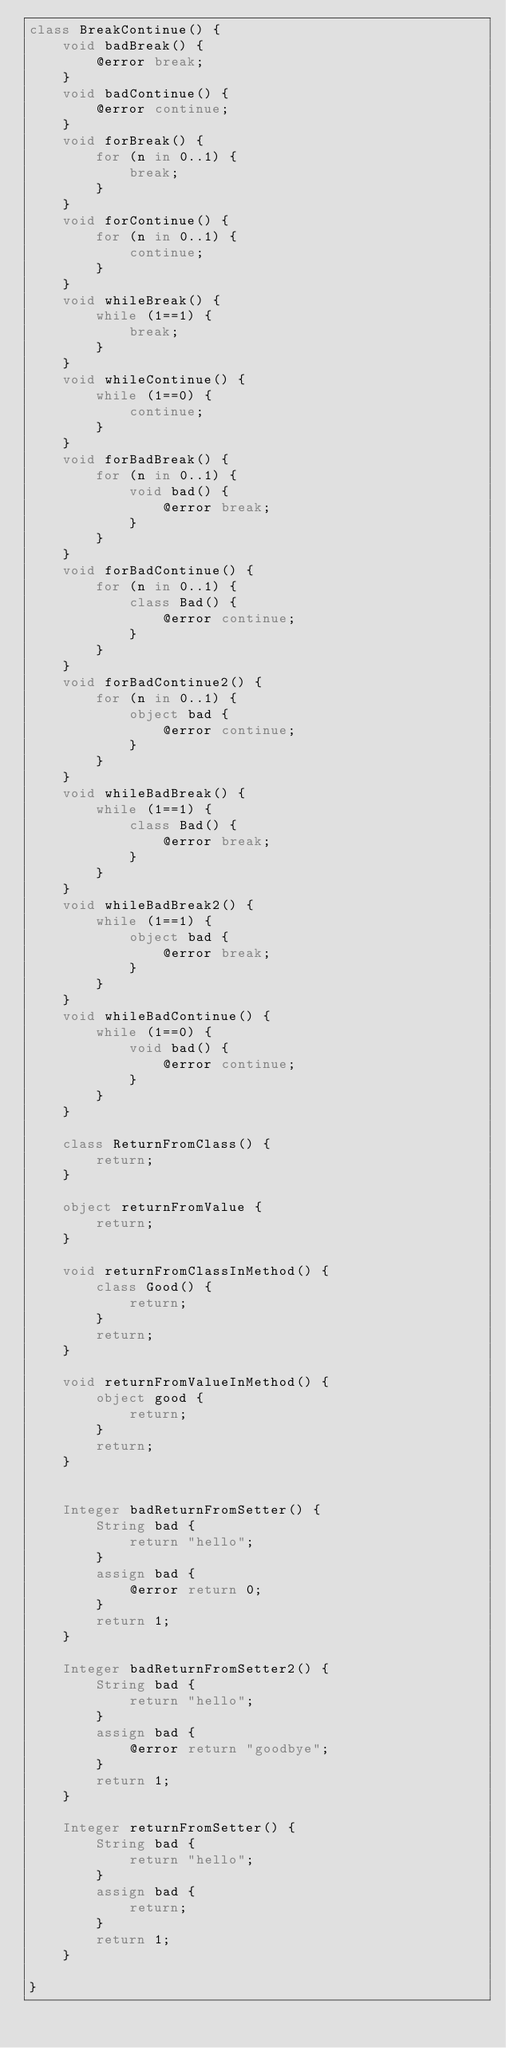Convert code to text. <code><loc_0><loc_0><loc_500><loc_500><_Ceylon_>class BreakContinue() {
    void badBreak() {
        @error break;
    }
    void badContinue() {
        @error continue;
    }
    void forBreak() {
        for (n in 0..1) {
            break;
        }
    }
    void forContinue() {
        for (n in 0..1) {
            continue;
        }
    }
    void whileBreak() {
        while (1==1) {
            break;
        }
    }
    void whileContinue() {
        while (1==0) {
            continue;
        }
    }
    void forBadBreak() {
        for (n in 0..1) {
            void bad() {
                @error break;
            }
        }
    }
    void forBadContinue() {
        for (n in 0..1) {
            class Bad() {
                @error continue;
            }
        }
    }
    void forBadContinue2() {
        for (n in 0..1) {
            object bad {
                @error continue;
            }
        }
    }
    void whileBadBreak() {
        while (1==1) {
            class Bad() {
                @error break;
            }
        }
    }
    void whileBadBreak2() {
        while (1==1) {
            object bad {
                @error break;
            }
        }
    }
    void whileBadContinue() {
        while (1==0) {
            void bad() {
                @error continue;
            }
        }
    }
    
    class ReturnFromClass() {
        return;
    }
    
    object returnFromValue {
        return;
    }
    
    void returnFromClassInMethod() {
        class Good() {
            return;
        }
        return;
    }
    
    void returnFromValueInMethod() {
        object good {
            return;
        }
        return;
    }
    
    
    Integer badReturnFromSetter() {
        String bad {
            return "hello";
        }
        assign bad {
            @error return 0;
        }
        return 1;
    }
    
    Integer badReturnFromSetter2() {
        String bad {
            return "hello";
        }
        assign bad {
            @error return "goodbye";
        }
        return 1;
    }
    
    Integer returnFromSetter() {
        String bad {
            return "hello";
        }
        assign bad {
            return;
        }
        return 1;
    }
    
}</code> 